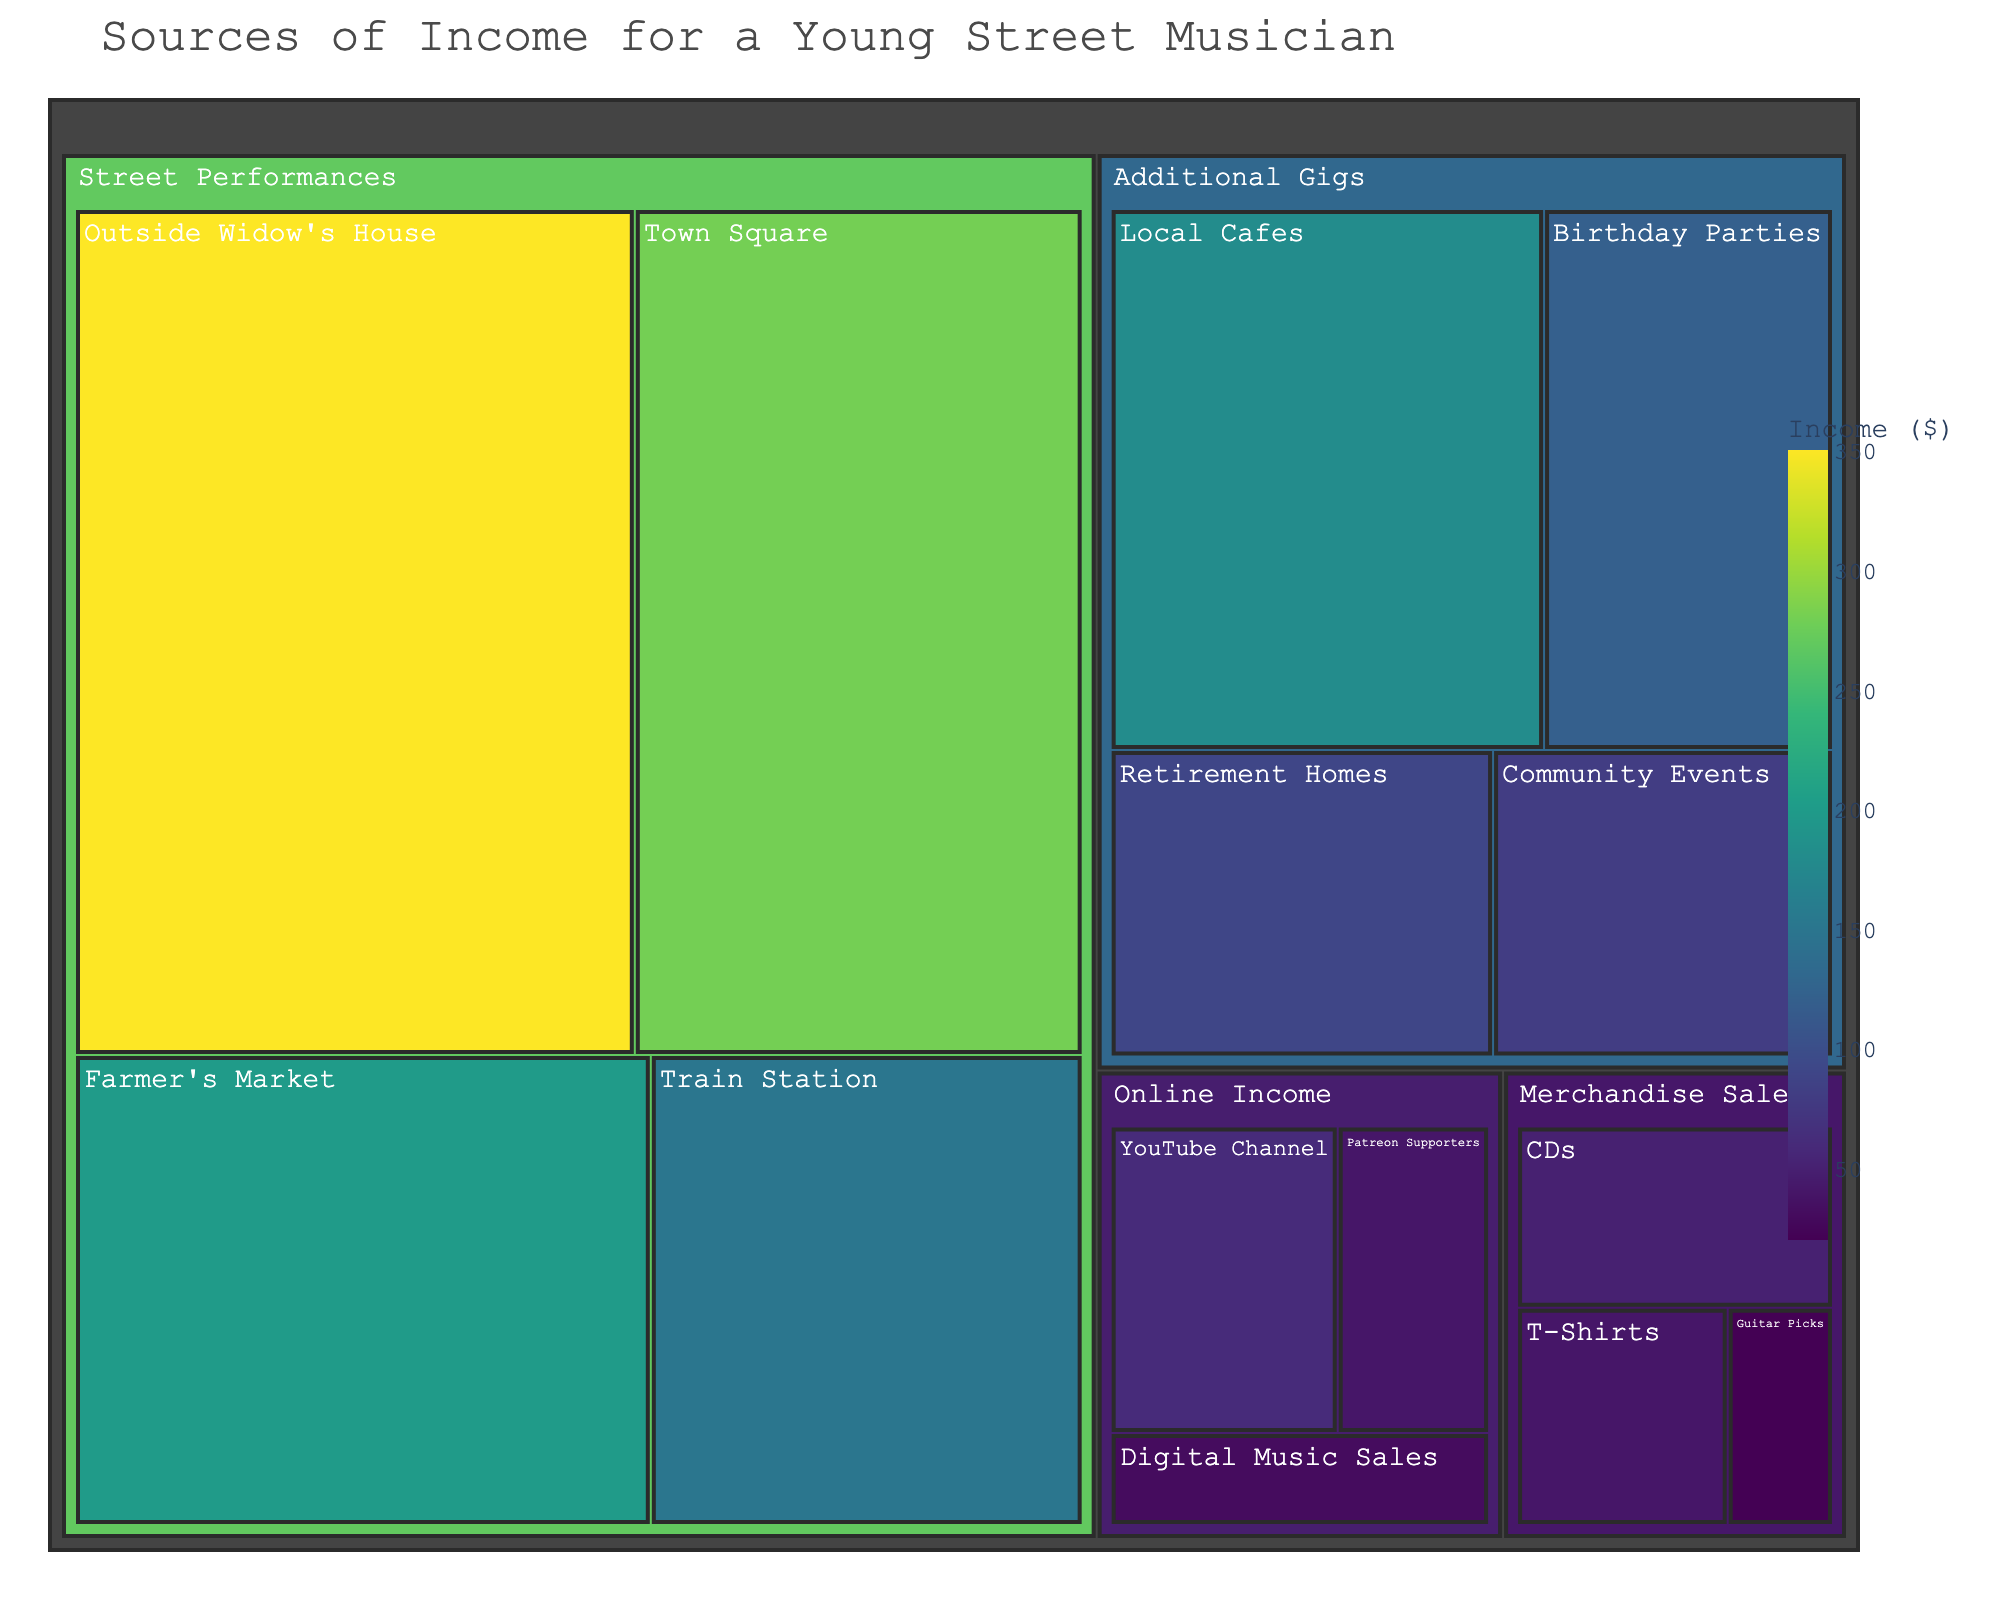What is the title of the treemap? The title of the treemap is displayed at the top of the figure.
Answer: Sources of Income for a Young Street Musician Which subcategory under "Additional Gigs" has the highest income? Under "Additional Gigs", the subcategory with the highest value can be identified by looking at the largest tile in this section of the treemap.
Answer: Local Cafes What is the total income from "Street Performances"? Sum the values of all subcategories under "Street Performances": 350 + 280 + 200 + 150.
Answer: 980 Compare the income from "YouTube Channel" and "Patreon Supporters". Which one generates more income? Compare the values for "YouTube Channel" (60) and "Patreon Supporters" (40).
Answer: YouTube Channel What is the least profitable subcategory under "Merchandise Sales"? The smallest tile under the "Merchandise Sales" category indicates the least profitable subcategory.
Answer: Guitar Picks How does the income from "Birthday Parties" compare to that from "Retirement Homes"? Compare the values for "Birthday Parties" (120) and "Retirement Homes" (90).
Answer: Birthday Parties generate more income What is the combined income from "Online Income"? Sum the values of all subcategories under "Online Income": 60 + 40 + 30.
Answer: 130 Which performance venue outside brings the highest income? Identify the subcategory under "Street Performances" with the highest value by size and color intensity.
Answer: Outside Widow's House Rank the subcategories under "Street Performances" from highest to lowest income. List subcategories under "Street Performances" by descending order of their value: Outside Widow's House (350), Town Square (280), Farmer's Market (200), Train Station (150).
Answer: Outside Widow's House, Town Square, Farmer's Market, Train Station Out of all income sources, which source generates the highest income? Locate the largest and most intense colored tile across all categories.
Answer: Outside Widow's House 